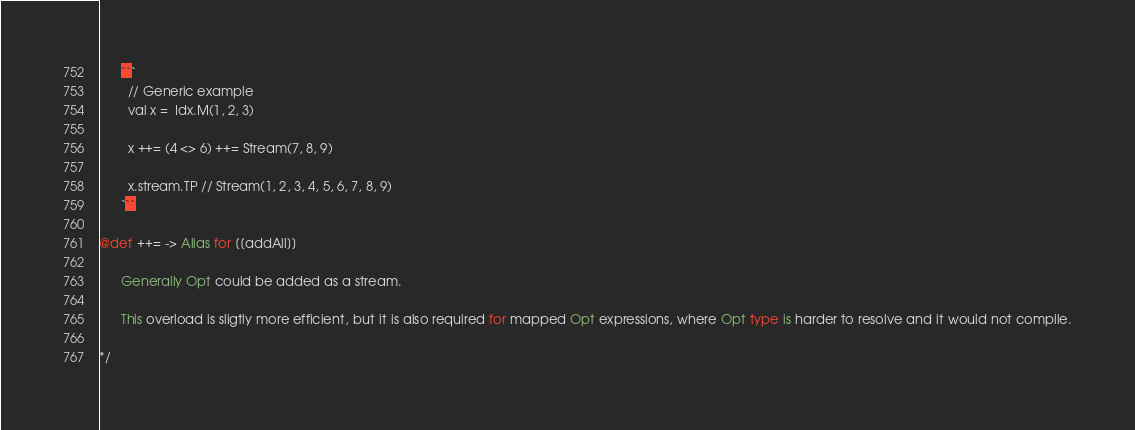<code> <loc_0><loc_0><loc_500><loc_500><_Scala_>      ```
        // Generic example
        val x =  Idx.M(1, 2, 3)

        x ++= (4 <> 6) ++= Stream(7, 8, 9)

        x.stream.TP // Stream(1, 2, 3, 4, 5, 6, 7, 8, 9)
      ```

@def ++= -> Alias for [[addAll]]

      Generally Opt could be added as a stream.

      This overload is sligtly more efficient, but it is also required for mapped Opt expressions, where Opt type is harder to resolve and it would not compile.

*/
</code> 